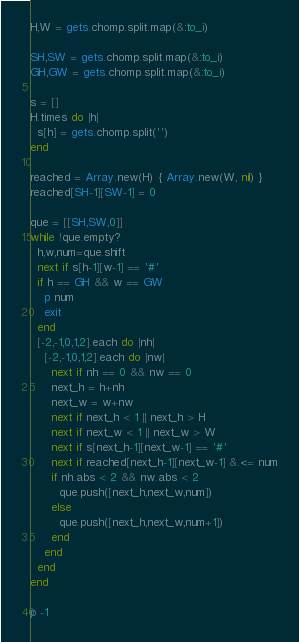<code> <loc_0><loc_0><loc_500><loc_500><_Ruby_>H,W = gets.chomp.split.map(&:to_i)

SH,SW = gets.chomp.split.map(&:to_i)
GH,GW = gets.chomp.split.map(&:to_i)

s = []
H.times do |h|
  s[h] = gets.chomp.split('')
end

reached = Array.new(H) { Array.new(W, nil) }
reached[SH-1][SW-1] = 0

que = [[SH,SW,0]]
while !que.empty?
  h,w,num=que.shift
  next if s[h-1][w-1] == '#'
  if h == GH && w == GW
    p num
    exit
  end
  [-2,-1,0,1,2].each do |nh|
    [-2,-1,0,1,2].each do |nw|
      next if nh == 0 && nw == 0
      next_h = h+nh
      next_w = w+nw
      next if next_h < 1 || next_h > H
      next if next_w < 1 || next_w > W
      next if s[next_h-1][next_w-1] == '#'
      next if reached[next_h-1][next_w-1] &.<= num
      if nh.abs < 2 && nw.abs < 2
        que.push([next_h,next_w,num])
      else
        que.push([next_h,next_w,num+1])
      end
    end
  end
end

p -1
</code> 